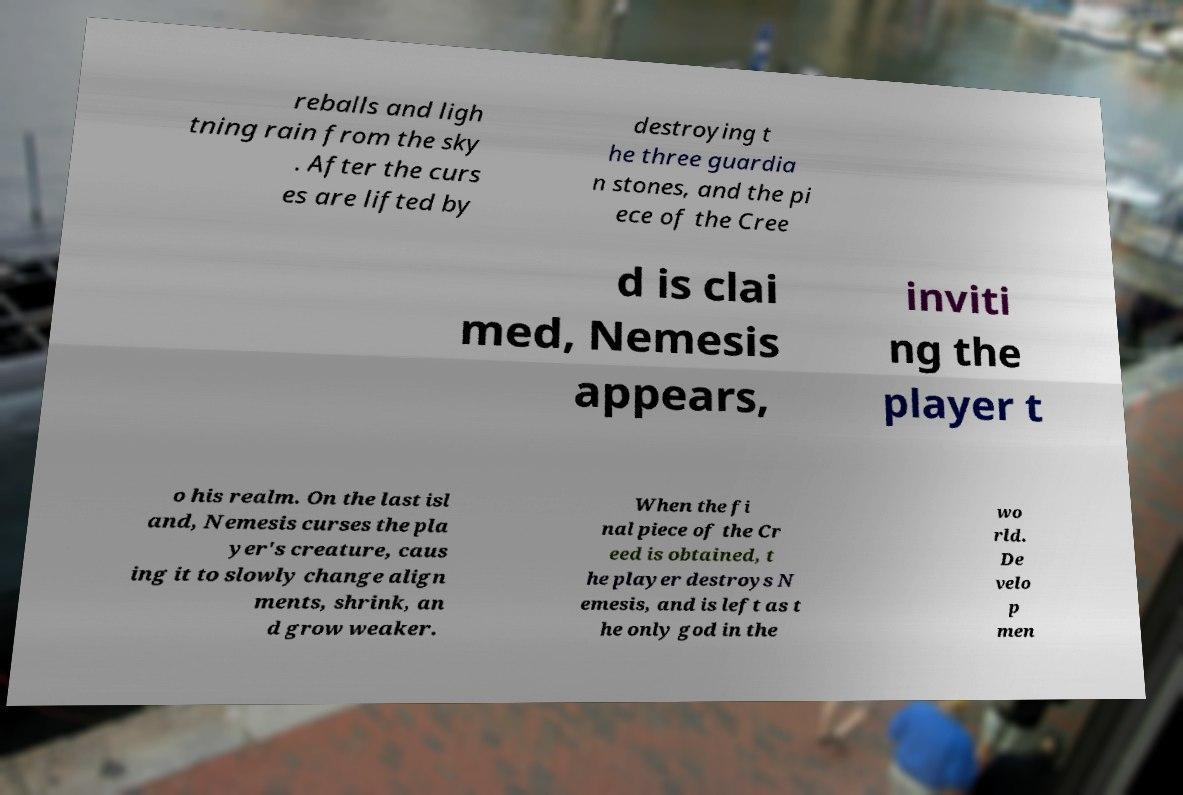I need the written content from this picture converted into text. Can you do that? reballs and ligh tning rain from the sky . After the curs es are lifted by destroying t he three guardia n stones, and the pi ece of the Cree d is clai med, Nemesis appears, inviti ng the player t o his realm. On the last isl and, Nemesis curses the pla yer's creature, caus ing it to slowly change align ments, shrink, an d grow weaker. When the fi nal piece of the Cr eed is obtained, t he player destroys N emesis, and is left as t he only god in the wo rld. De velo p men 